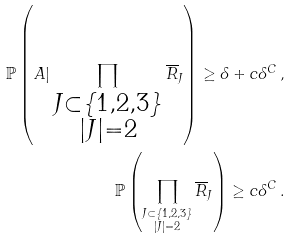<formula> <loc_0><loc_0><loc_500><loc_500>\mathbb { P } \left ( A | \prod _ { \substack { J \subset \{ 1 , 2 , 3 \} \\ | J | = 2 } } \overline { R } _ { J } \right ) \geq \delta + c \delta ^ { C } \, , \\ \mathbb { P } \left ( \prod _ { \substack { J \subset \{ 1 , 2 , 3 \} \\ | J | = 2 } } \overline { R } _ { J } \right ) \geq c \delta ^ { C } \, .</formula> 